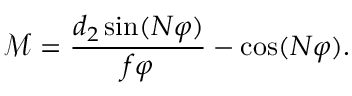<formula> <loc_0><loc_0><loc_500><loc_500>\mathcal { M } = \frac { d _ { 2 } \sin ( N \varphi ) } { f \varphi } - \cos ( N \varphi ) .</formula> 